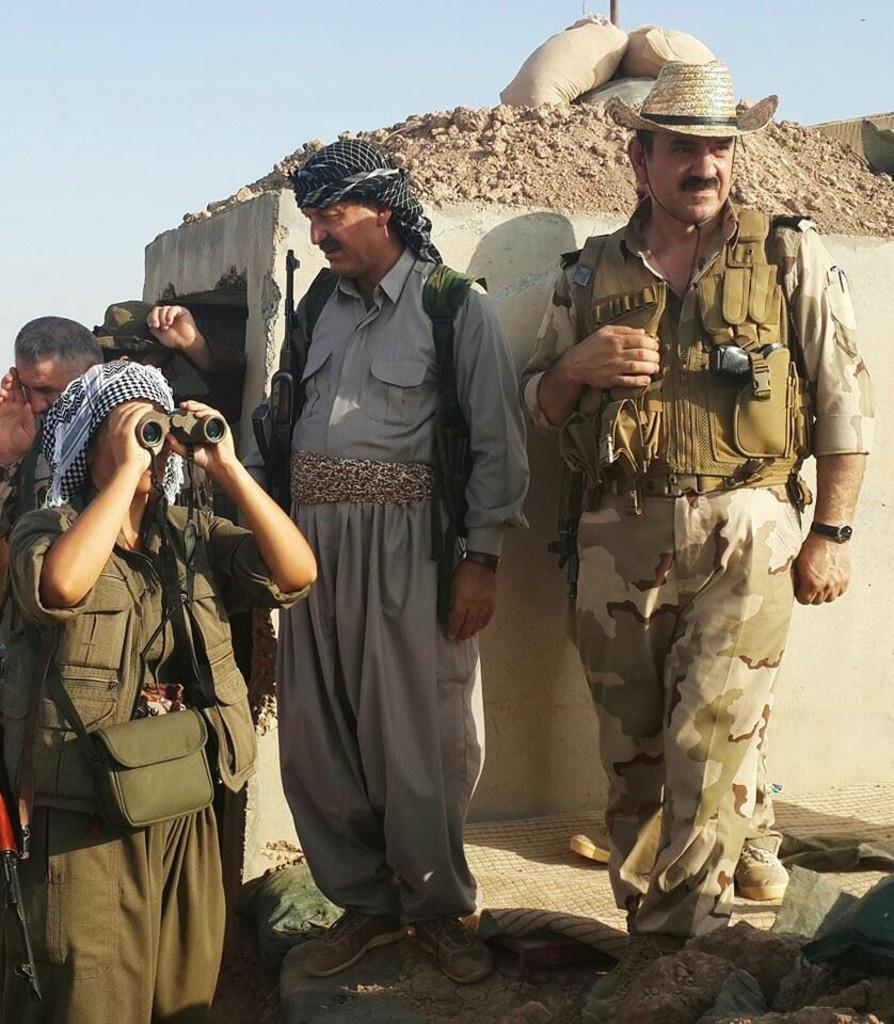Please provide a concise description of this image. This picture shows the the military man wearing green color dress and cowboy hat on the head looking on the right side. Beside we can see a man wearing and traditional dress with gun standing on seeing on the left side. Behind there is small damage wall with some sand. On the left side there is a man wearing green jacket and a bag looking straight from the binocular. 